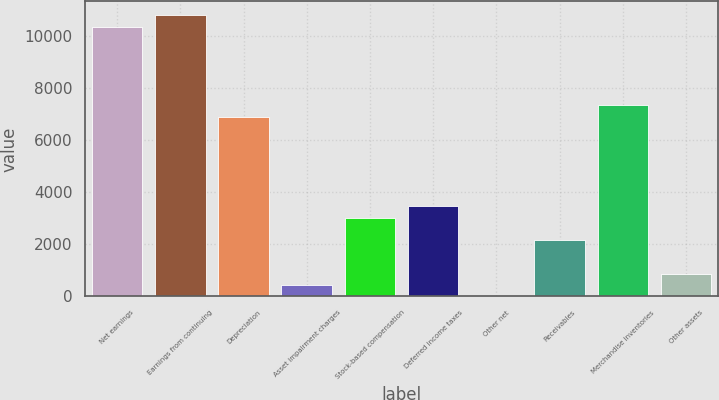Convert chart to OTSL. <chart><loc_0><loc_0><loc_500><loc_500><bar_chart><fcel>Net earnings<fcel>Earnings from continuing<fcel>Depreciation<fcel>Asset impairment charges<fcel>Stock-based compensation<fcel>Deferred income taxes<fcel>Other net<fcel>Receivables<fcel>Merchandise inventories<fcel>Other assets<nl><fcel>10361.4<fcel>10793<fcel>6908.6<fcel>434.6<fcel>3024.2<fcel>3455.8<fcel>3<fcel>2161<fcel>7340.2<fcel>866.2<nl></chart> 